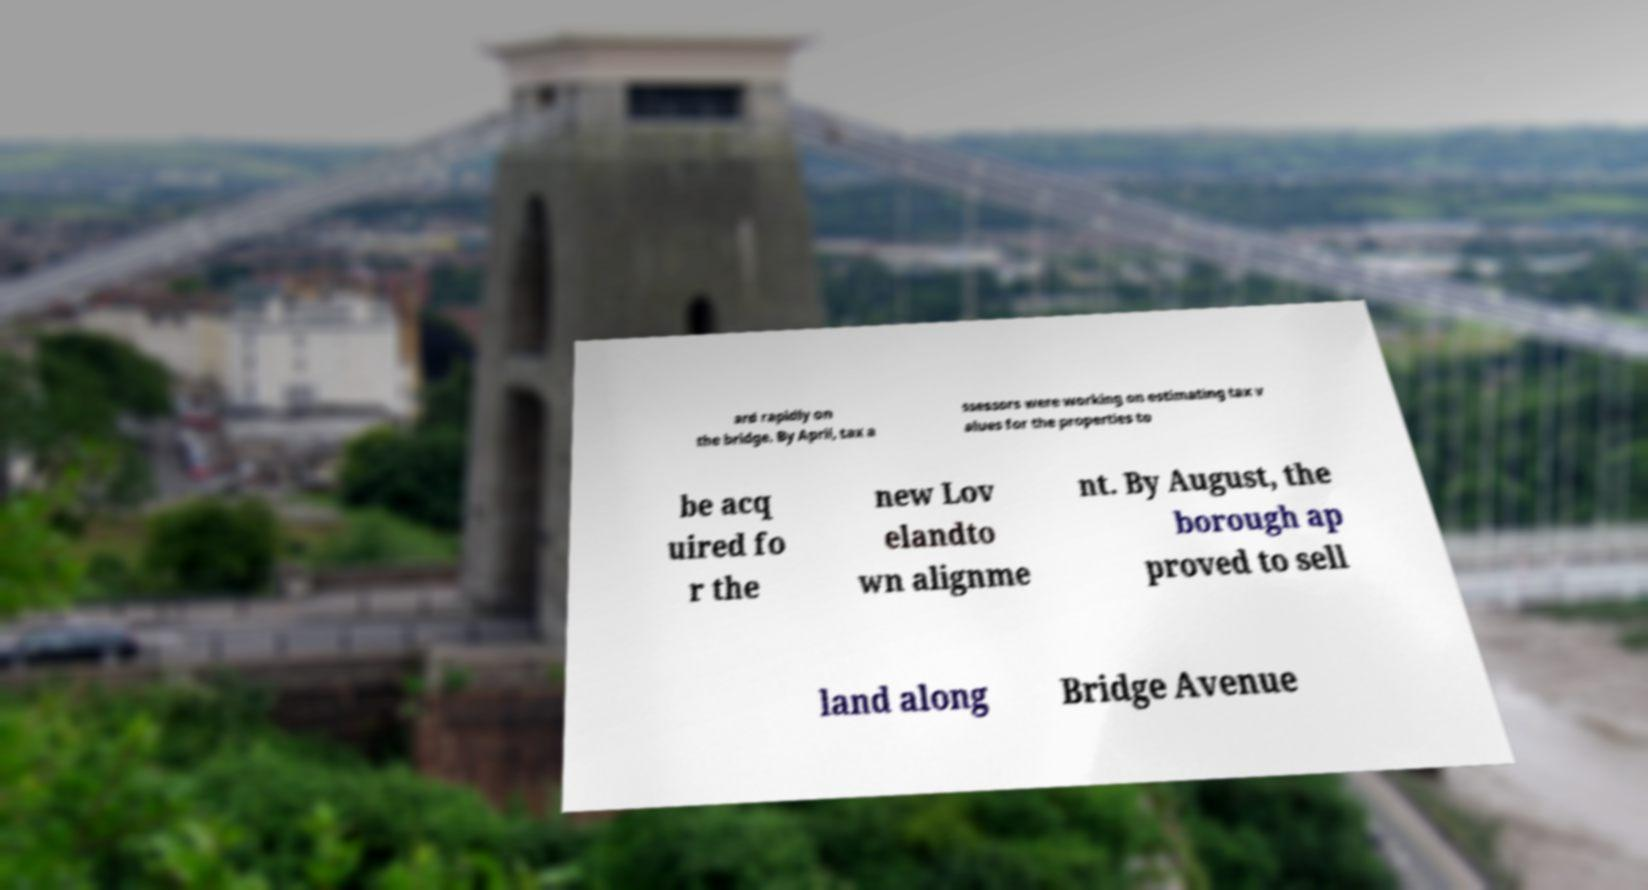Could you extract and type out the text from this image? ard rapidly on the bridge. By April, tax a ssessors were working on estimating tax v alues for the properties to be acq uired fo r the new Lov elandto wn alignme nt. By August, the borough ap proved to sell land along Bridge Avenue 